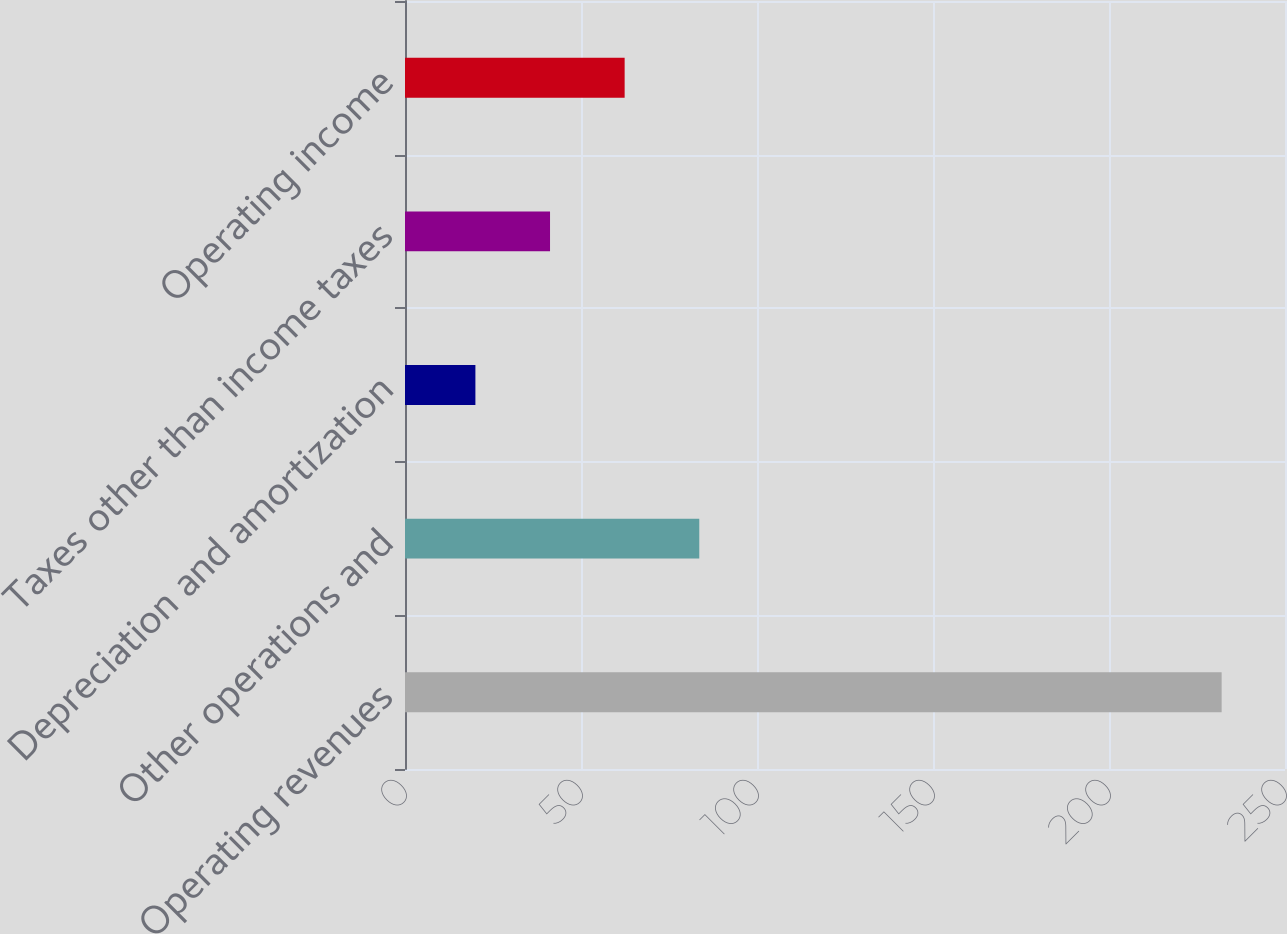Convert chart to OTSL. <chart><loc_0><loc_0><loc_500><loc_500><bar_chart><fcel>Operating revenues<fcel>Other operations and<fcel>Depreciation and amortization<fcel>Taxes other than income taxes<fcel>Operating income<nl><fcel>232<fcel>83.6<fcel>20<fcel>41.2<fcel>62.4<nl></chart> 